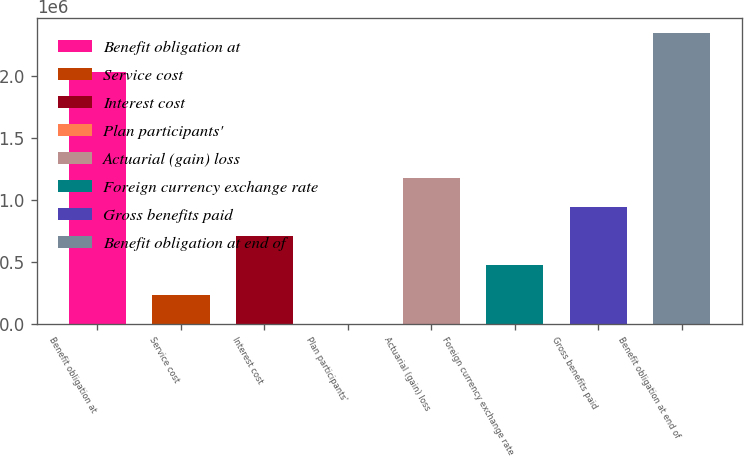Convert chart to OTSL. <chart><loc_0><loc_0><loc_500><loc_500><bar_chart><fcel>Benefit obligation at<fcel>Service cost<fcel>Interest cost<fcel>Plan participants'<fcel>Actuarial (gain) loss<fcel>Foreign currency exchange rate<fcel>Gross benefits paid<fcel>Benefit obligation at end of<nl><fcel>2.03518e+06<fcel>238383<fcel>708096<fcel>3526<fcel>1.17781e+06<fcel>473240<fcel>942953<fcel>2.35209e+06<nl></chart> 